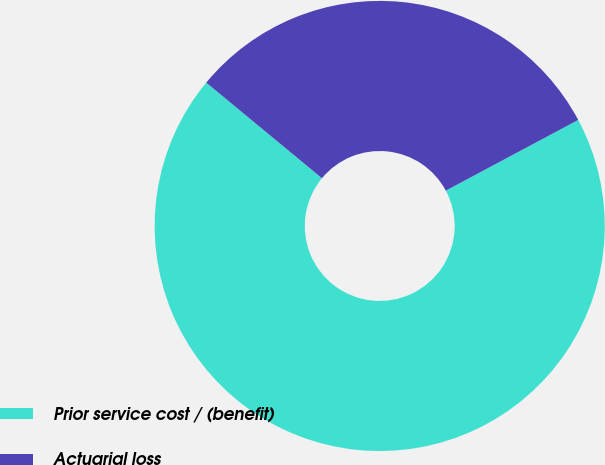<chart> <loc_0><loc_0><loc_500><loc_500><pie_chart><fcel>Prior service cost / (benefit)<fcel>Actuarial loss<nl><fcel>68.8%<fcel>31.2%<nl></chart> 